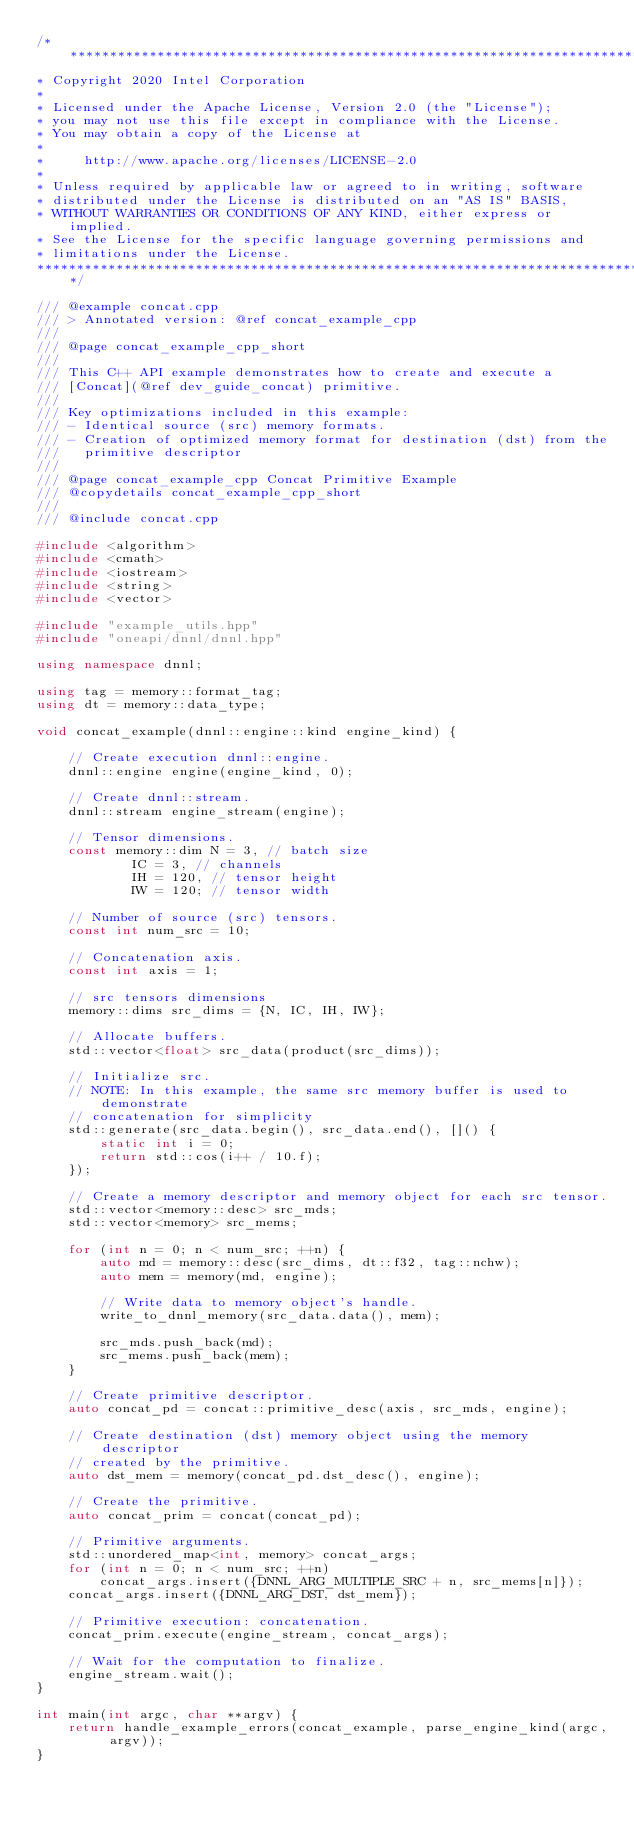Convert code to text. <code><loc_0><loc_0><loc_500><loc_500><_C++_>/*******************************************************************************
* Copyright 2020 Intel Corporation
*
* Licensed under the Apache License, Version 2.0 (the "License");
* you may not use this file except in compliance with the License.
* You may obtain a copy of the License at
*
*     http://www.apache.org/licenses/LICENSE-2.0
*
* Unless required by applicable law or agreed to in writing, software
* distributed under the License is distributed on an "AS IS" BASIS,
* WITHOUT WARRANTIES OR CONDITIONS OF ANY KIND, either express or implied.
* See the License for the specific language governing permissions and
* limitations under the License.
*******************************************************************************/

/// @example concat.cpp
/// > Annotated version: @ref concat_example_cpp
///
/// @page concat_example_cpp_short
///
/// This C++ API example demonstrates how to create and execute a
/// [Concat](@ref dev_guide_concat) primitive.
///
/// Key optimizations included in this example:
/// - Identical source (src) memory formats.
/// - Creation of optimized memory format for destination (dst) from the
///   primitive descriptor
///
/// @page concat_example_cpp Concat Primitive Example
/// @copydetails concat_example_cpp_short
///
/// @include concat.cpp

#include <algorithm>
#include <cmath>
#include <iostream>
#include <string>
#include <vector>

#include "example_utils.hpp"
#include "oneapi/dnnl/dnnl.hpp"

using namespace dnnl;

using tag = memory::format_tag;
using dt = memory::data_type;

void concat_example(dnnl::engine::kind engine_kind) {

    // Create execution dnnl::engine.
    dnnl::engine engine(engine_kind, 0);

    // Create dnnl::stream.
    dnnl::stream engine_stream(engine);

    // Tensor dimensions.
    const memory::dim N = 3, // batch size
            IC = 3, // channels
            IH = 120, // tensor height
            IW = 120; // tensor width

    // Number of source (src) tensors.
    const int num_src = 10;

    // Concatenation axis.
    const int axis = 1;

    // src tensors dimensions
    memory::dims src_dims = {N, IC, IH, IW};

    // Allocate buffers.
    std::vector<float> src_data(product(src_dims));

    // Initialize src.
    // NOTE: In this example, the same src memory buffer is used to demonstrate
    // concatenation for simplicity
    std::generate(src_data.begin(), src_data.end(), []() {
        static int i = 0;
        return std::cos(i++ / 10.f);
    });

    // Create a memory descriptor and memory object for each src tensor.
    std::vector<memory::desc> src_mds;
    std::vector<memory> src_mems;

    for (int n = 0; n < num_src; ++n) {
        auto md = memory::desc(src_dims, dt::f32, tag::nchw);
        auto mem = memory(md, engine);

        // Write data to memory object's handle.
        write_to_dnnl_memory(src_data.data(), mem);

        src_mds.push_back(md);
        src_mems.push_back(mem);
    }

    // Create primitive descriptor.
    auto concat_pd = concat::primitive_desc(axis, src_mds, engine);

    // Create destination (dst) memory object using the memory descriptor
    // created by the primitive.
    auto dst_mem = memory(concat_pd.dst_desc(), engine);

    // Create the primitive.
    auto concat_prim = concat(concat_pd);

    // Primitive arguments.
    std::unordered_map<int, memory> concat_args;
    for (int n = 0; n < num_src; ++n)
        concat_args.insert({DNNL_ARG_MULTIPLE_SRC + n, src_mems[n]});
    concat_args.insert({DNNL_ARG_DST, dst_mem});

    // Primitive execution: concatenation.
    concat_prim.execute(engine_stream, concat_args);

    // Wait for the computation to finalize.
    engine_stream.wait();
}

int main(int argc, char **argv) {
    return handle_example_errors(concat_example, parse_engine_kind(argc, argv));
}
</code> 